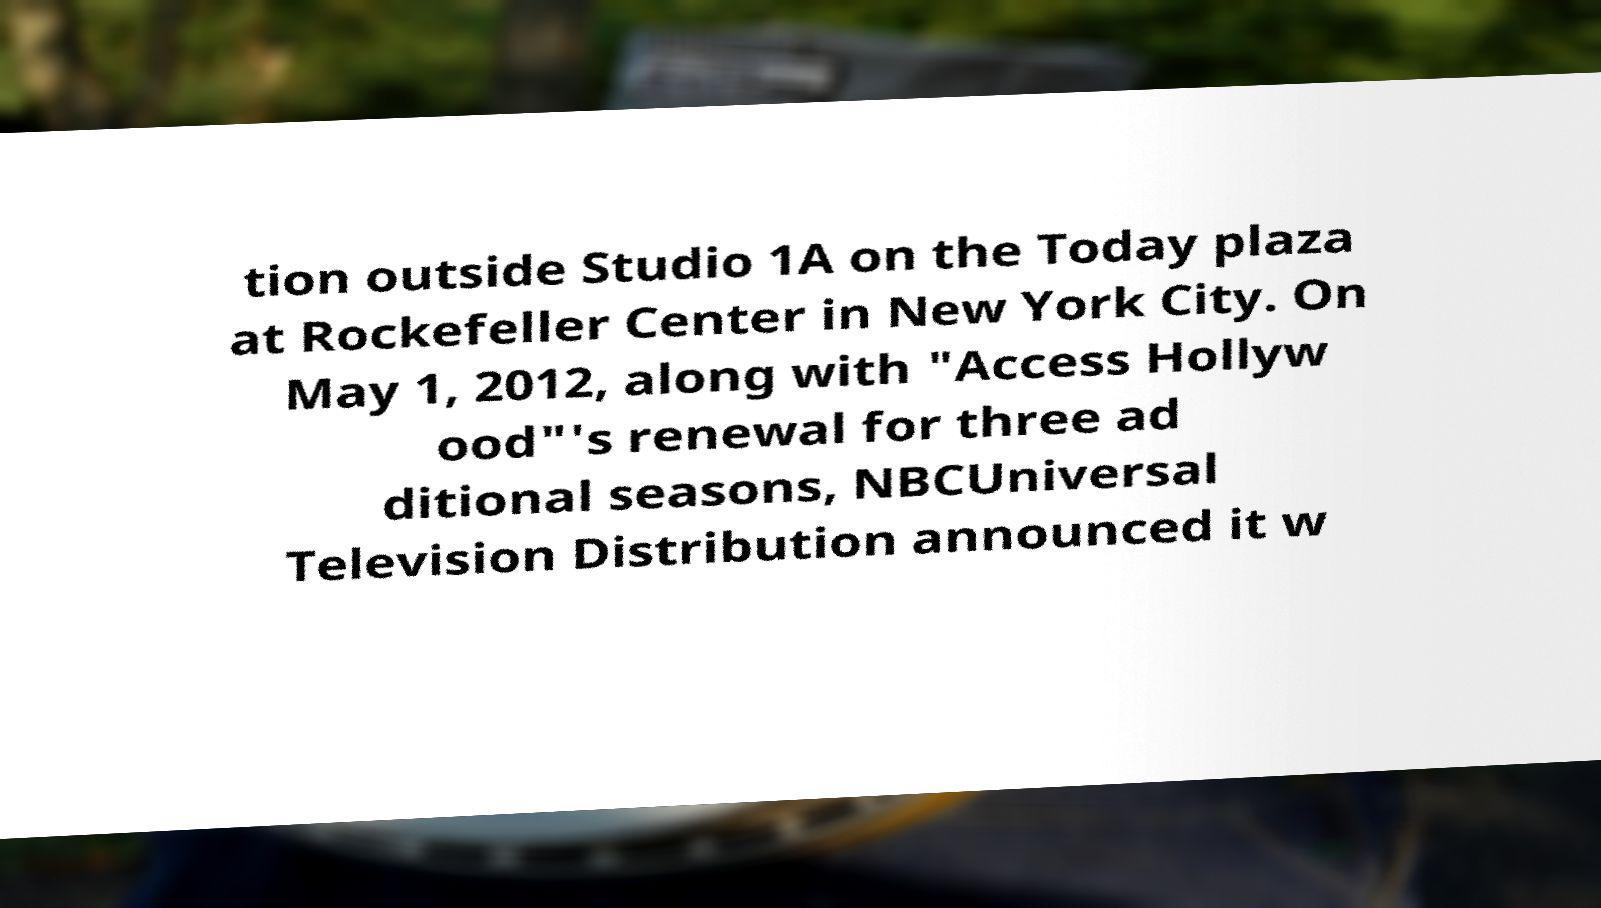Could you extract and type out the text from this image? tion outside Studio 1A on the Today plaza at Rockefeller Center in New York City. On May 1, 2012, along with "Access Hollyw ood"'s renewal for three ad ditional seasons, NBCUniversal Television Distribution announced it w 